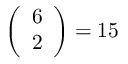<formula> <loc_0><loc_0><loc_500><loc_500>{ \left ( \begin{array} { l } { 6 } \\ { 2 } \end{array} \right ) } = 1 5</formula> 